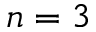<formula> <loc_0><loc_0><loc_500><loc_500>n = 3</formula> 